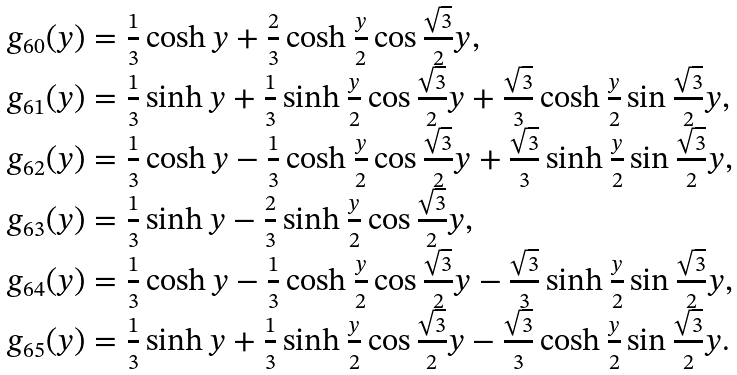<formula> <loc_0><loc_0><loc_500><loc_500>\begin{array} { l } g _ { 6 0 } ( y ) = \frac { 1 } { 3 } \cosh y + \frac { 2 } { 3 } \cosh \frac { y } { 2 } \cos \frac { \sqrt { 3 } } { 2 } y , \\ g _ { 6 1 } ( y ) = \frac { 1 } { 3 } \sinh y + \frac { 1 } { 3 } \sinh \frac { y } { 2 } \cos \frac { \sqrt { 3 } } { 2 } y + \frac { \sqrt { 3 } } { 3 } \cosh \frac { y } { 2 } \sin \frac { \sqrt { 3 } } { 2 } y , \\ g _ { 6 2 } ( y ) = \frac { 1 } { 3 } \cosh y - \frac { 1 } { 3 } \cosh \frac { y } { 2 } \cos \frac { \sqrt { 3 } } { 2 } y + \frac { \sqrt { 3 } } { 3 } \sinh \frac { y } { 2 } \sin \frac { \sqrt { 3 } } { 2 } y , \\ g _ { 6 3 } ( y ) = \frac { 1 } { 3 } \sinh y - \frac { 2 } { 3 } \sinh \frac { y } { 2 } \cos \frac { \sqrt { 3 } } { 2 } y , \\ g _ { 6 4 } ( y ) = \frac { 1 } { 3 } \cosh y - \frac { 1 } { 3 } \cosh \frac { y } { 2 } \cos \frac { \sqrt { 3 } } { 2 } y - \frac { \sqrt { 3 } } { 3 } \sinh \frac { y } { 2 } \sin \frac { \sqrt { 3 } } { 2 } y , \\ g _ { 6 5 } ( y ) = \frac { 1 } { 3 } \sinh y + \frac { 1 } { 3 } \sinh \frac { y } { 2 } \cos \frac { \sqrt { 3 } } { 2 } y - \frac { \sqrt { 3 } } { 3 } \cosh \frac { y } { 2 } \sin \frac { \sqrt { 3 } } { 2 } y . \end{array}</formula> 